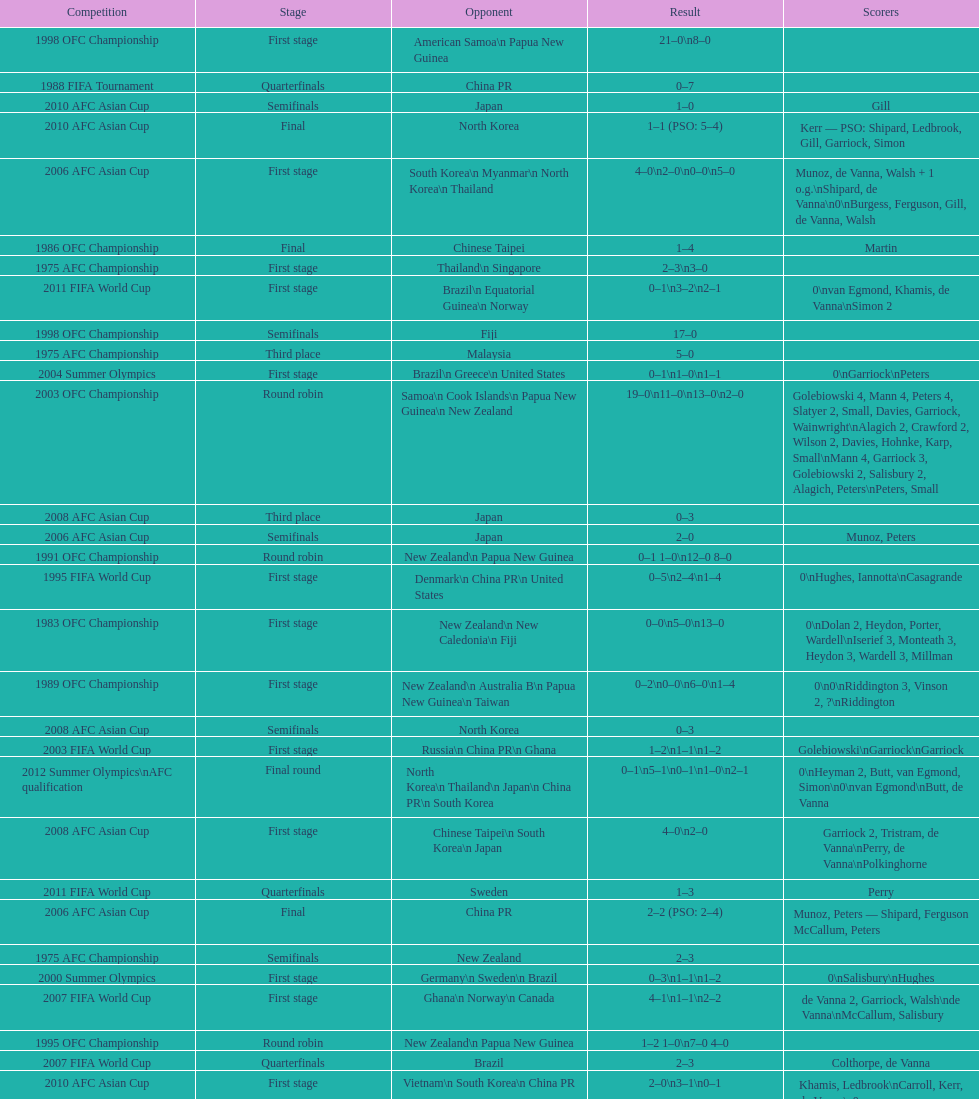How many stages were round robins? 3. 